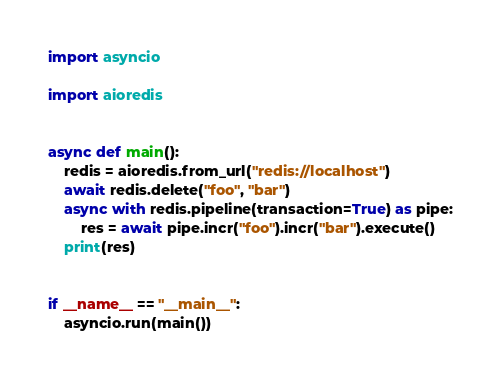<code> <loc_0><loc_0><loc_500><loc_500><_Python_>import asyncio

import aioredis


async def main():
    redis = aioredis.from_url("redis://localhost")
    await redis.delete("foo", "bar")
    async with redis.pipeline(transaction=True) as pipe:
        res = await pipe.incr("foo").incr("bar").execute()
    print(res)


if __name__ == "__main__":
    asyncio.run(main())
</code> 